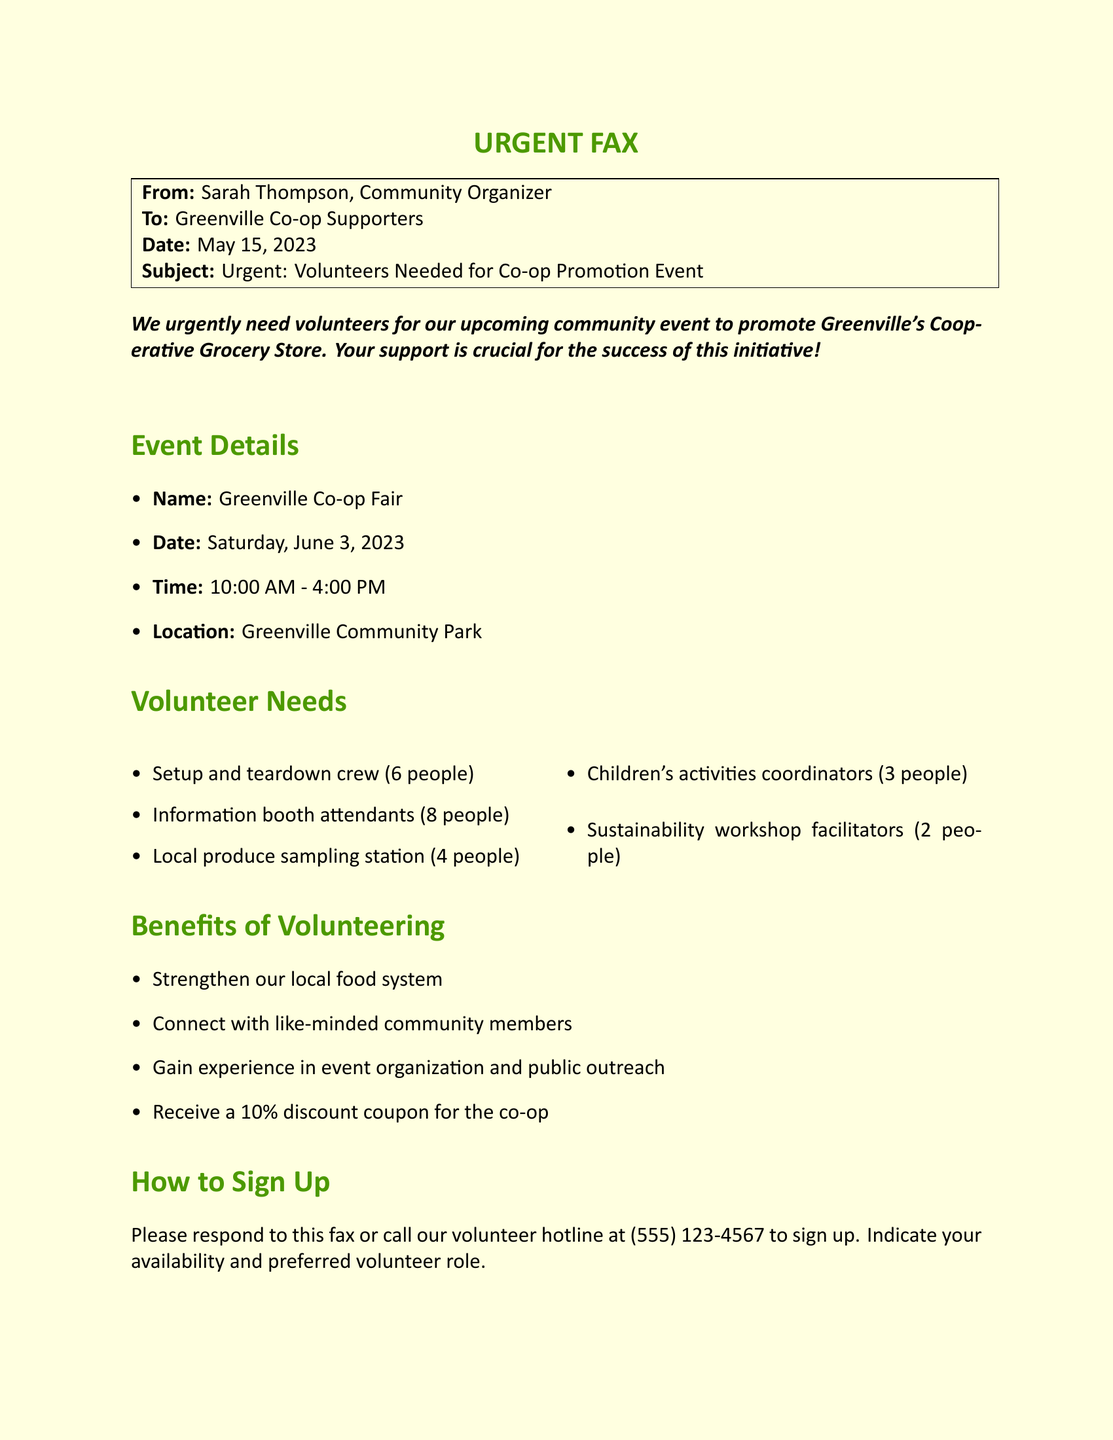What is the date of the event? The date of the event is explicitly mentioned in the document.
Answer: June 3, 2023 How long is the event scheduled to last? The document specifies the start and end time of the event.
Answer: 6 hours How many volunteers are needed for the information booth? The document lists the number of volunteers required for each role, including the information booth.
Answer: 8 people Who is the sender of this fax? The sender's name is provided at the top of the document.
Answer: Sarah Thompson What is one benefit of volunteering mentioned in the document? The document lists several benefits, highlighting one of them for quick reference.
Answer: 10% discount coupon What is the location of the Greenville Co-op Fair? The document provides the event location in a bullet point.
Answer: Greenville Community Park How many children's activities coordinators are needed? The document explicitly states the number of children's activities coordinators required.
Answer: 3 people What action should you take to sign up as a volunteer? The document describes the method for signing up to volunteer.
Answer: Call the volunteer hotline 